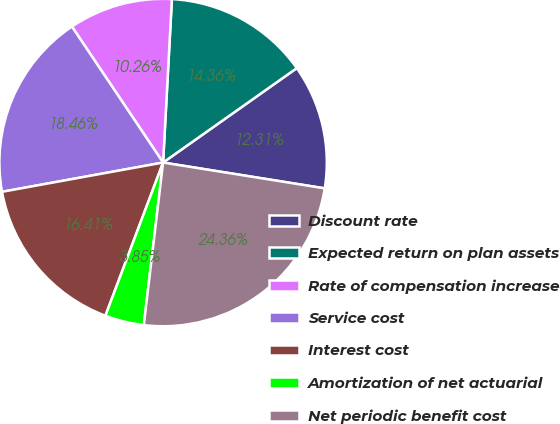<chart> <loc_0><loc_0><loc_500><loc_500><pie_chart><fcel>Discount rate<fcel>Expected return on plan assets<fcel>Rate of compensation increase<fcel>Service cost<fcel>Interest cost<fcel>Amortization of net actuarial<fcel>Net periodic benefit cost<nl><fcel>12.31%<fcel>14.36%<fcel>10.26%<fcel>18.46%<fcel>16.41%<fcel>3.85%<fcel>24.36%<nl></chart> 